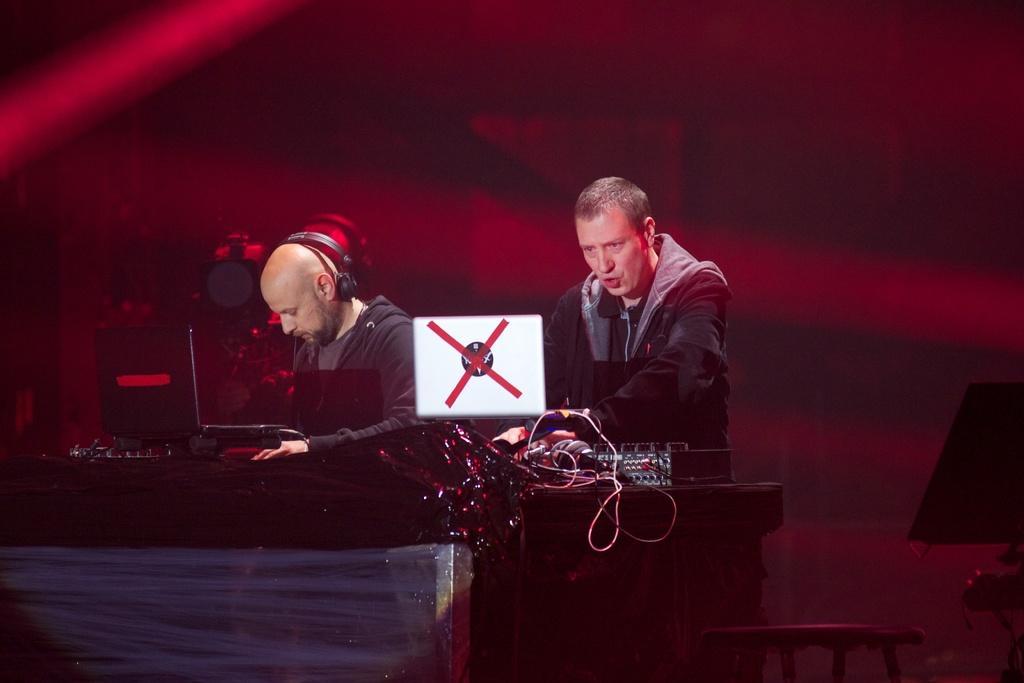How would you summarize this image in a sentence or two? In this image in the center there is a table, on the table there are musical instruments and behind the table there are persons standing and there are lights. On the right side there is an object which is black in colour. 